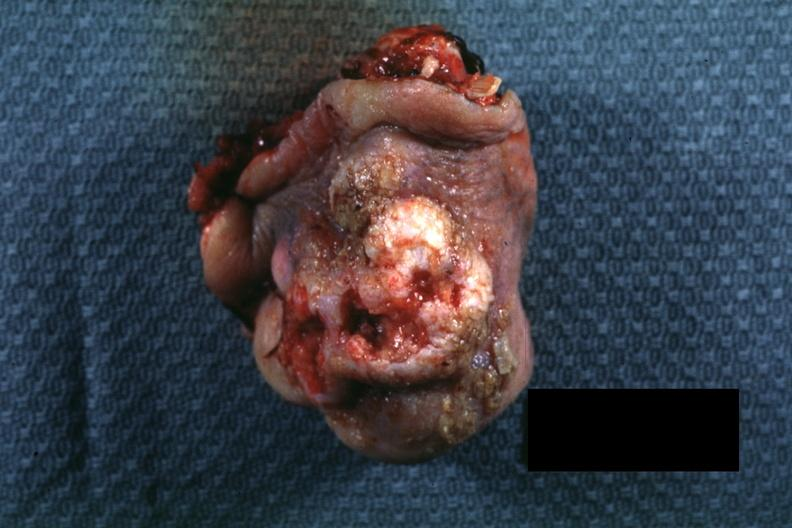where is this?
Answer the question using a single word or phrase. Skin 